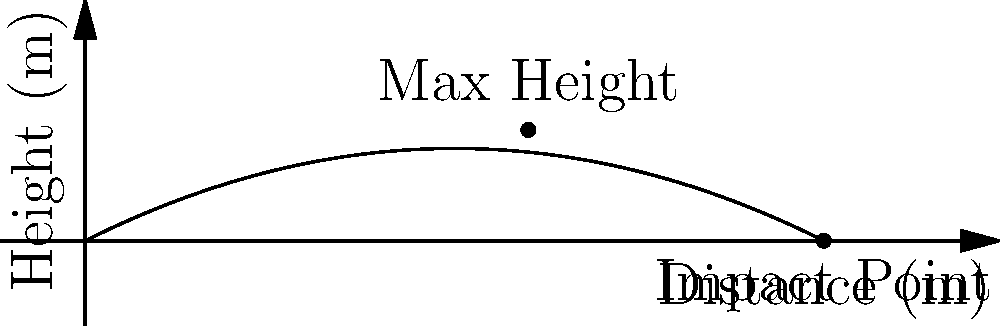In a historical battle, a cannonball is fired from ground level. Its trajectory is modeled by the quadratic function $h(x) = -0.005x^2 + 0.5x$, where $h$ is the height in meters and $x$ is the horizontal distance in meters. Calculate:

a) The maximum height reached by the cannonball.
b) The horizontal distance at which the cannonball hits the ground.
c) The angle of elevation (in degrees) at which the cannon was fired. Let's approach this step-by-step:

a) To find the maximum height:
   1. The vertex of a parabola gives the maximum height for a projectile motion.
   2. For a quadratic function $f(x) = ax^2 + bx + c$, the x-coordinate of the vertex is given by $x = -\frac{b}{2a}$.
   3. Here, $a = -0.005$ and $b = 0.5$
   4. $x = -\frac{0.5}{2(-0.005)} = 50$ meters
   5. The maximum height is $h(50) = -0.005(50)^2 + 0.5(50) = 12.5$ meters

b) To find the impact point:
   1. The impact point is where the height is zero: $h(x) = 0$
   2. Solve $-0.005x^2 + 0.5x = 0$
   3. Factor out x: $x(-0.005x + 0.5) = 0$
   4. $x = 0$ or $x = 100$
   5. Since $x = 0$ is the starting point, the impact is at $x = 100$ meters

c) For the angle of elevation:
   1. The slope of the tangent line at $x = 0$ gives the initial trajectory.
   2. The derivative of $h(x)$ is $h'(x) = -0.01x + 0.5$
   3. At $x = 0$, $h'(0) = 0.5$
   4. The angle of elevation is $\theta = \arctan(0.5)$
   5. Converting to degrees: $\theta = \arctan(0.5) * \frac{180}{\pi} \approx 26.57°$
Answer: a) 12.5 m
b) 100 m
c) 26.57° 